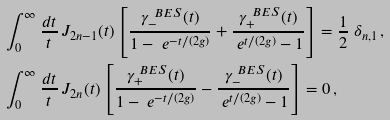Convert formula to latex. <formula><loc_0><loc_0><loc_500><loc_500>& \int _ { 0 } ^ { \infty } \frac { d t } { t } \, J _ { 2 n - 1 } ( t ) \left [ \frac { \gamma ^ { \ B E S } _ { - } ( t ) } { 1 - \ e ^ { - t / ( 2 g ) } } + \frac { \gamma ^ { \ B E S } _ { + } ( t ) } { \ e ^ { t / ( 2 g ) } - 1 } \right ] = \frac { 1 } { 2 } \ \delta _ { n , 1 } \, , \\ & \int _ { 0 } ^ { \infty } \frac { d t } { t } \, J _ { 2 n } ( t ) \left [ \frac { \gamma ^ { \ B E S } _ { + } ( t ) } { 1 - \ e ^ { - t / ( 2 g ) } } - \frac { \gamma ^ { \ B E S } _ { - } ( t ) } { \ e ^ { t / ( 2 g ) } - 1 } \right ] = 0 \, ,</formula> 